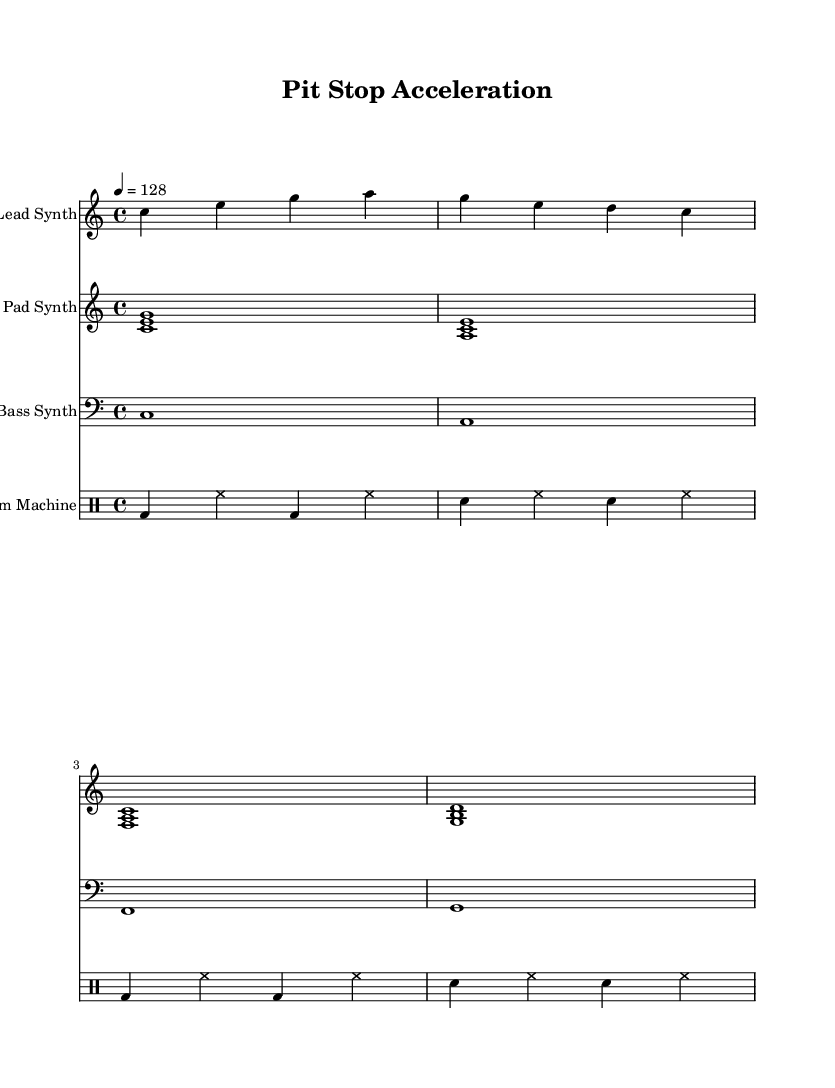What is the key signature of this music? The key signature is C major, which has no sharps or flats indicated in the sheet music.
Answer: C major What is the time signature of this music? The time signature of the music is 4/4, which is indicated at the beginning of the score. This means there are four beats in each measure, and a quarter note gets one beat.
Answer: 4/4 What is the tempo marking of this piece? The tempo marking indicates that the piece should be played at a tempo of 128 beats per minute, as specified in the score.
Answer: 128 How many measures are in the drum part? The drum part contains a total of 4 measures, as shown by the grouping of notes in the drum notation. Each measure includes two sequences of beat patterns repeated throughout.
Answer: 4 Which instrument has the highest melodic range? The lead synth part has the highest melodic range, starting from the note C on the second octave and reaching up to A, which indicates it plays higher than the other parts.
Answer: Lead Synth What type of synthesis is predominant in this music? Synthesizer sounds are predominant, specifically through the lead synth, pad synth, and bass synth, each creating a different texture in the overall sound composition.
Answer: Synthesizer How is the bass synth part structured? The bass synth part is structured with a slow rhythm, consisting of whole notes that create a solid foundation underneath the faster-moving synthesizer melodies above.
Answer: Whole notes 